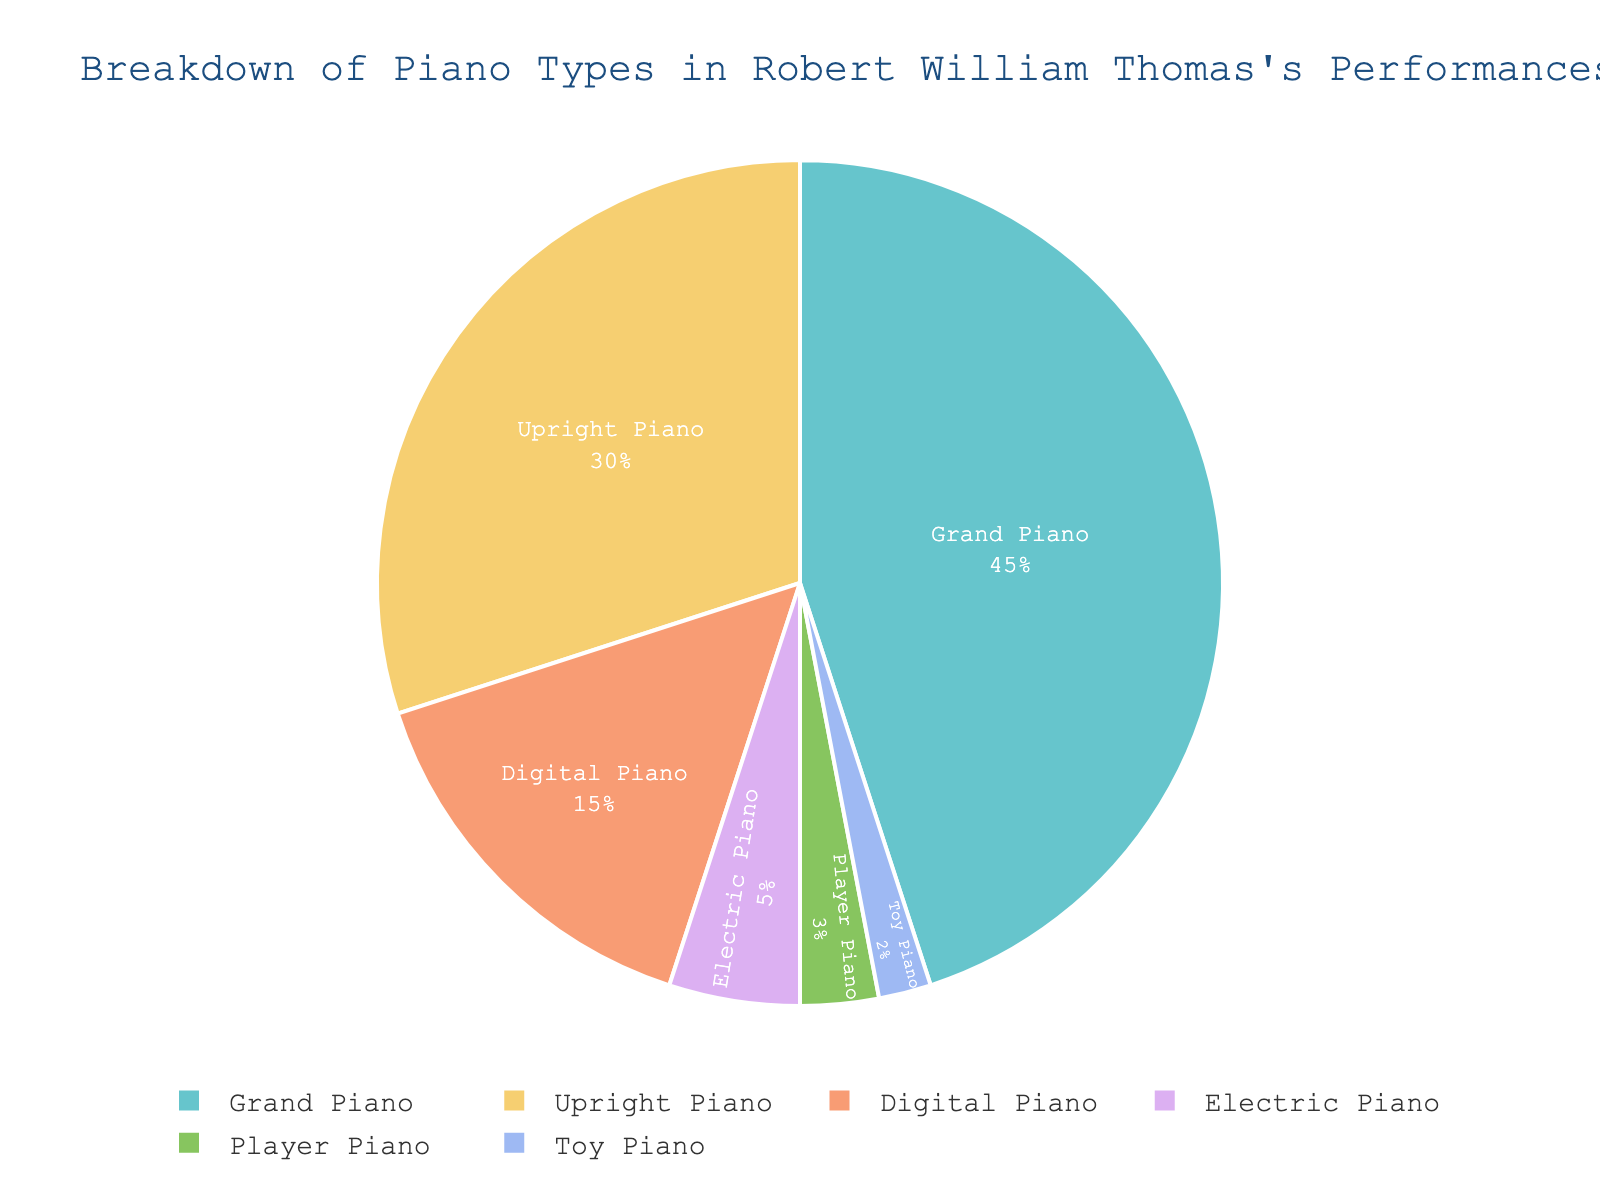What percentage of Thomas's performances used a Grand Piano? The figure shows a pie chart with various types of pianos. From the chart, the segment for Grand Piano indicates a value of 45%.
Answer: 45% Which two piano types make up exactly half of Thomas's performances? The figure indicates that Grand Piano accounts for 45% and Upright Piano accounts for 30%, together making 75%. For exactly half, Grand Piano (45%) and Digital Piano (15%) sum up to exactly 60%, which is not correct. Therefore, the actual answer should sum to 50%, which is not directly indicated on the chart. However, a closer look shows Upright Piano (30%) and Digital Piano (15%) add up to 45%, if combined with Toy Piano (2%) and Player Piano (3%), they together add up to 50%
Answer: Upright Piano and Digital Piano How many piano types make up less than 10% of Thomas's performances each? The pie chart segments for Electric Piano (5%), Player Piano (3%), and Toy Piano (2%) are each below 10%.
Answer: 3 Which piano type is used the least in Thomas's performances? The smallest segment on the pie chart represents Toy Piano with a value of 2%.
Answer: Toy Piano What is the combined percentage of Electric Piano and Player Piano use? According to the pie chart, Electric Piano is 5% and Player Piano is 3%. Adding these together gives 5% + 3% = 8%.
Answer: 8% How many more times is a Grand Piano used compared to a Toy Piano in Thomas's performances? The figure shows that Grand Piano is 45% and Toy Piano is 2%. To find how many more times Grand Piano is used: 45% / 2% = 22.5 times.
Answer: 22.5 times Compare the usage of Upright Piano and Digital Piano. Which one is used more, and by how much? From the pie chart, the Upright Piano use is 30% and Digital Piano use is 15%. The difference is 30% - 15% = 15%.
Answer: Upright Piano by 15% What fraction of Thomas's performances involve either an Upright Piano or a Digital Piano? The pie chart shows Upright Piano (30%) and Digital Piano (15%). The combined percentage is 30% + 15% = 45%. The fraction is therefore 45/100, simplifying to 9/20.
Answer: 9/20 What proportion of Thomas's performances used either a Player Piano or a Toy Piano? In Thomas's performances, Player Piano accounts for 3% and Toy Piano for 2%. Added together, the proportion is 3% + 2% = 5%.
Answer: 5% If we exclude all piano types that account for less than 10% of the performances, what percentage of performances do the remaining types contribute to? The piano types contributing less than 10% are Electric Piano (5%), Player Piano (3%), and Toy Piano (2%) which add up to 10%. Excluding these, the remaining types (Grand Piano, Upright Piano, and Digital Piano) together account for 100% - 10% = 90%.
Answer: 90% 